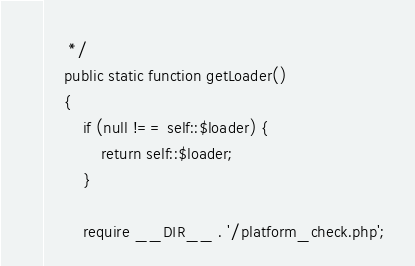<code> <loc_0><loc_0><loc_500><loc_500><_PHP_>     */
    public static function getLoader()
    {
        if (null !== self::$loader) {
            return self::$loader;
        }

        require __DIR__ . '/platform_check.php';
</code> 